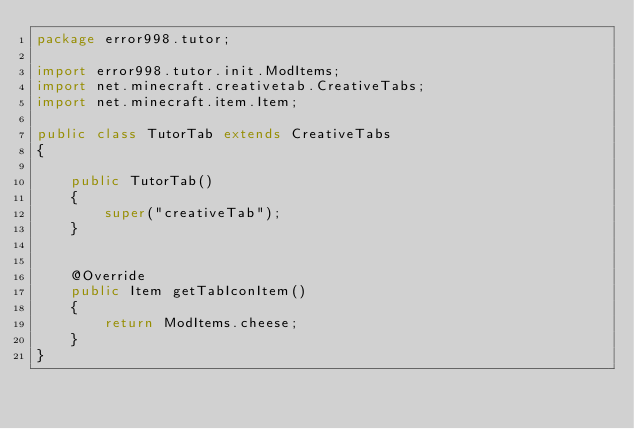Convert code to text. <code><loc_0><loc_0><loc_500><loc_500><_Java_>package error998.tutor;

import error998.tutor.init.ModItems;
import net.minecraft.creativetab.CreativeTabs;
import net.minecraft.item.Item;

public class TutorTab extends CreativeTabs
{

	public TutorTab()
	{
		super("creativeTab");
	}

	
	@Override
	public Item getTabIconItem()
	{
		return ModItems.cheese;
	}
}
</code> 